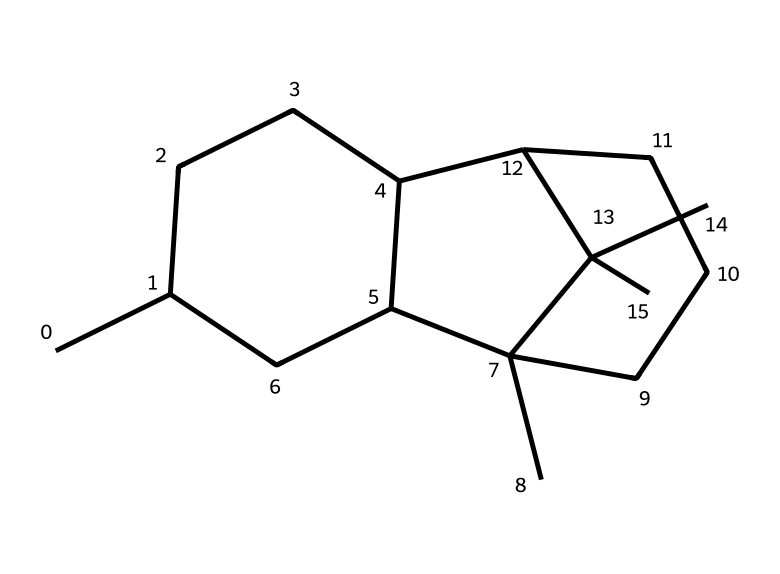What is the main class of this chemical compound? This chemical compound, based on its molecular structure containing predominantly carbon and hydrogen atoms, falls under the category of hydrocarbons. More specifically, it is an example of a cyclic alkane due to its ring-like structure.
Answer: hydrocarbons How many carbon atoms are present in the structure? By analyzing the SMILES representation, we can count the carbon atoms. Each "C" represents a carbon atom, and in the given structure, there are 15 carbon atoms present.
Answer: 15 What type of bonding is predominantly present in this molecule? The structure indicates single bonds between carbon atoms, characteristic of saturated hydrocarbons. In this molecule, there are only single bonds, indicating that it is a cycloalkane.
Answer: single bonds Does this chemical structure have any functional groups? The provided SMILES structure does not indicate the presence of any functional groups since it only includes carbon and hydrogen atoms in a cyclic form. Functional groups typically contain heteroatoms such as oxygen or nitrogen.
Answer: no What is the molecular formula derived from this structure? By counting the carbon and hydrogen atoms from the structure based on the SMILES notation, we can deduce that the molecular formula consists of C15H30, representing the composition of the molecule.
Answer: C15H30 Which characteristic property does this liquid possess due to its cyclic structure? The cyclic structure of this hydrocarbon contributes to its stability and generally low reactivity, which is a characteristic property of cyclic alkanes. This stability can lead to higher boiling points compared to non-cyclic counterparts.
Answer: stability 